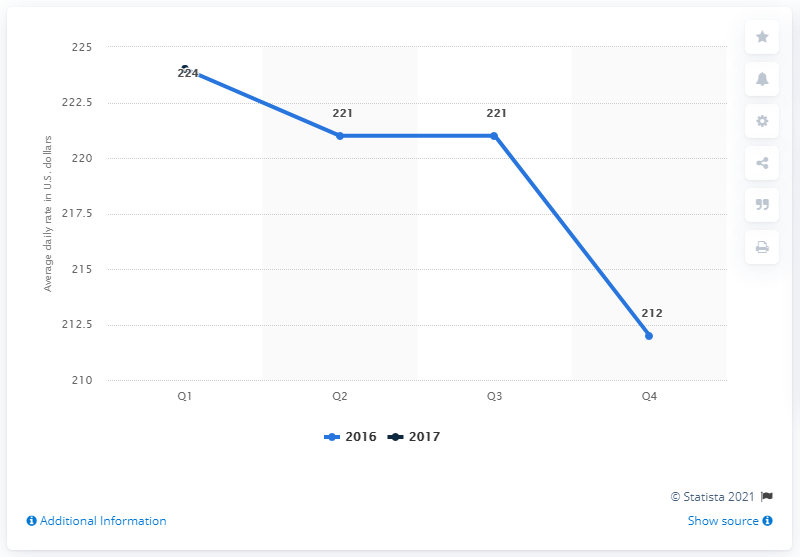Mention a couple of crucial points in this snapshot. In the first quarter of 2017, the average daily rate of hotels in Los Angeles, United States was 224 USD. 